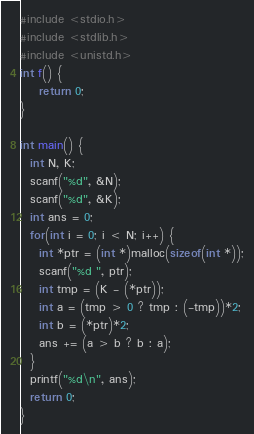<code> <loc_0><loc_0><loc_500><loc_500><_C_>#include <stdio.h>
#include <stdlib.h>
#include <unistd.h>
int f() {
    return 0;
}

int main() {
  int N, K;
  scanf("%d", &N);
  scanf("%d", &K);
  int ans = 0;
  for(int i = 0; i < N; i++) {
    int *ptr = (int *)malloc(sizeof(int *));
    scanf("%d ", ptr);
    int tmp = (K - (*ptr));
    int a = (tmp > 0 ? tmp : (-tmp))*2;
    int b = (*ptr)*2;
    ans += (a > b ? b : a);
  }
  printf("%d\n", ans);
  return 0;
}</code> 